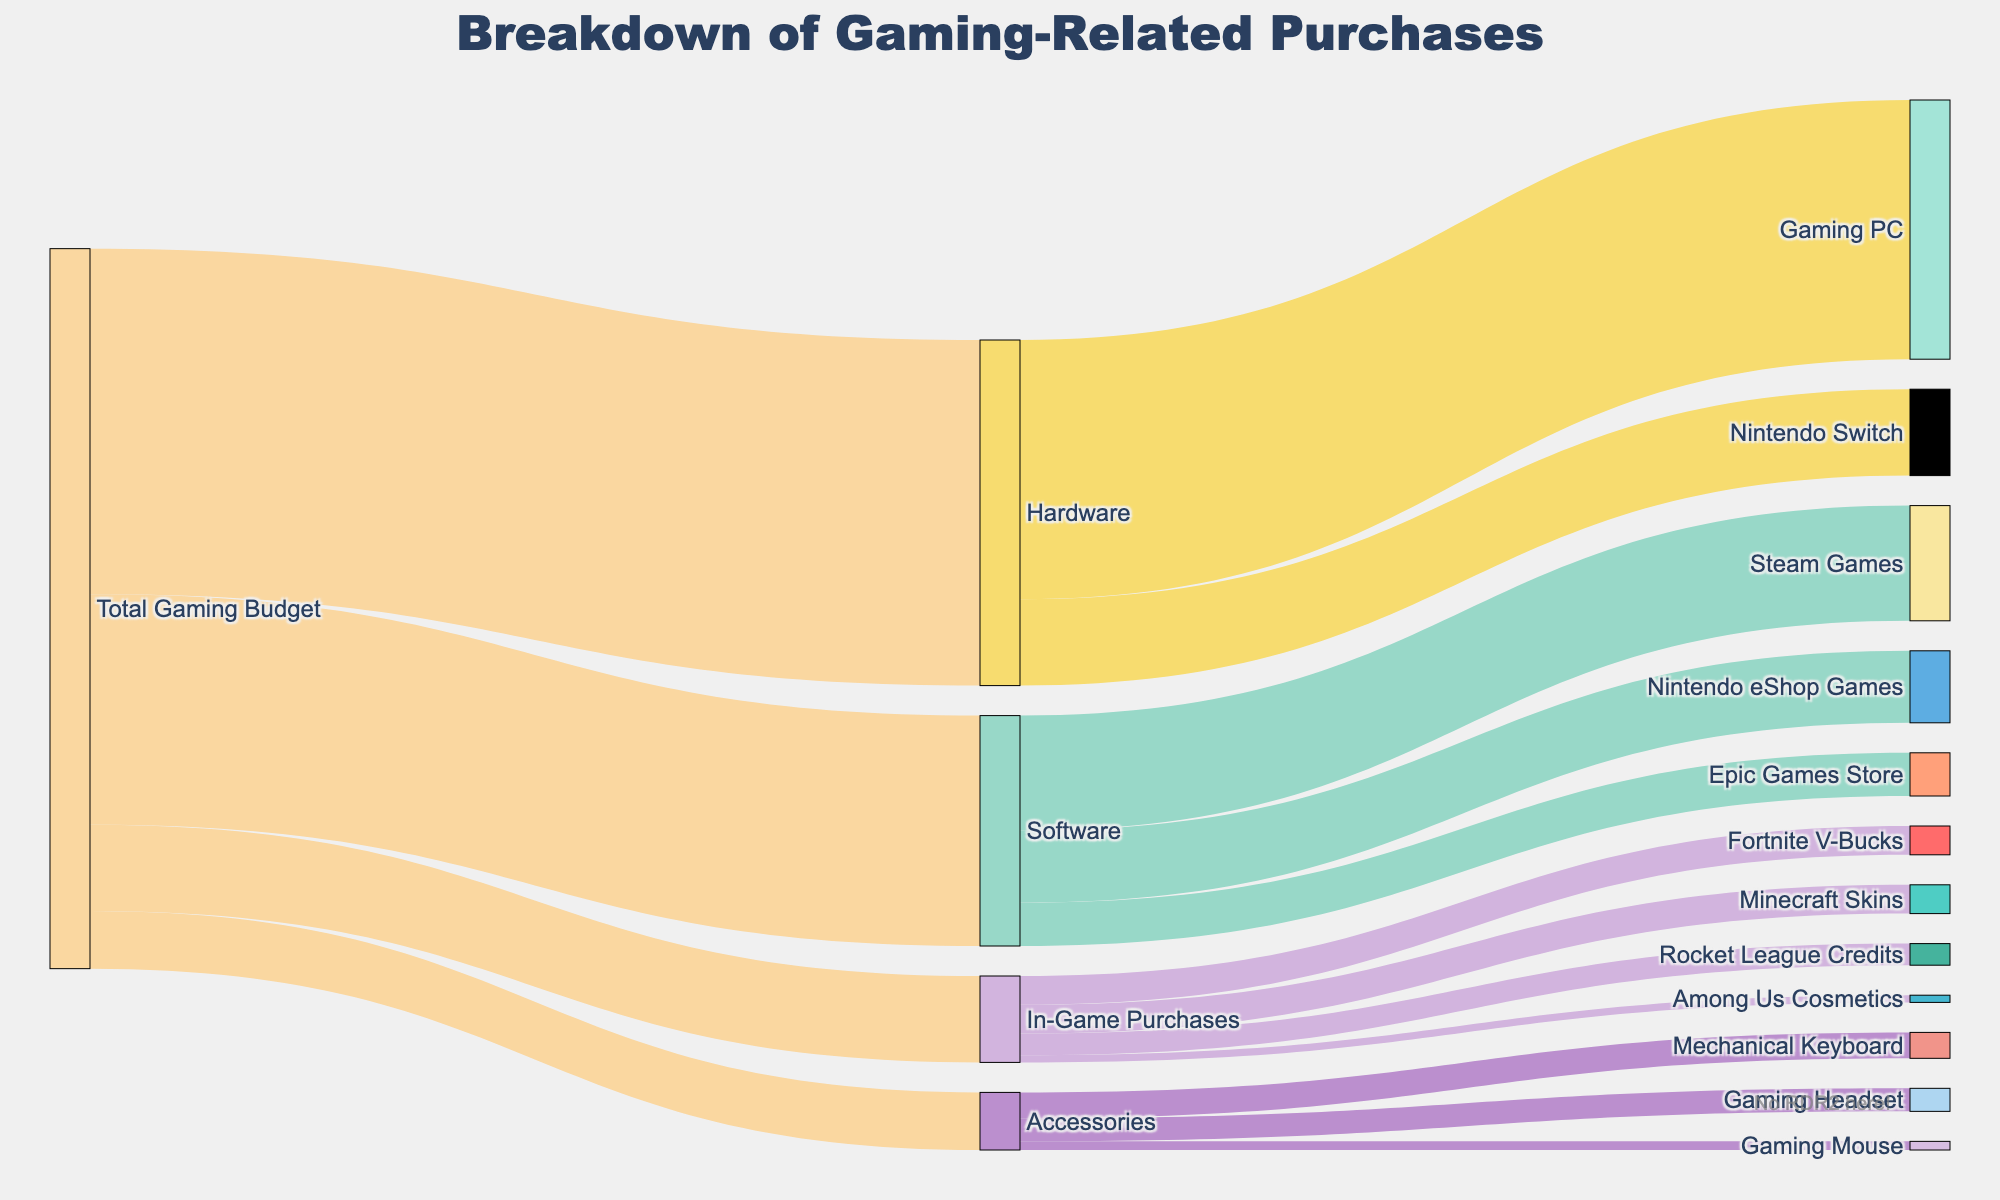How much is allocated to Hardware according to the diagram? Looking at the Sankey diagram, the flow from "Total Gaming Budget" to "Hardware" indicates the amount allocated.
Answer: 1200 Which category receives the least amount of money? By examining the flows from "Total Gaming Budget," we see the amounts are: Hardware (1200), Software (800), In-Game Purchases (300), and Accessories (200). The smallest amount is for Accessories.
Answer: Accessories How does the budget for Steam Games compare to Nintendo eShop Games? The Sankey diagram shows that "Steam Games" receive 400 and "Nintendo eShop Games" receive 250. Since 400 > 250, Steam Games receive more.
Answer: Steam Games receive more What is the sum of money spent on Gaming PC and Nintendo Switch? The amounts for "Gaming PC" and "Nintendo Switch" can be seen exiting from "Hardware." Summing them, we get 900 + 300 = 1200.
Answer: 1200 How much money is spent on Fortnite V-Bucks and Minecraft Skins combined? We see that "Fortnite V-Bucks" and "Minecraft Skins" are 100 each. Adding them results in 100 + 100 = 200.
Answer: 200 What percentage of the Total Gaming Budget is spent on Software? The total budget is 2500 (1200 + 800 + 300 + 200). Software expenditures are 800. So, (800 / 2500) * 100 = 32%.
Answer: 32% Is more money spent on Software or on Hardware? By viewing the diagram, we see that Software gets 800 while Hardware gets 1200. Hence, more is spent on Hardware.
Answer: Hardware Which in-game purchase has the highest expenditure? From the diagram, the in-game purchases are: Fortnite V-Bucks (100), Rocket League Credits (75), Among Us Cosmetics (25), Minecraft Skins (100). The highest is Fortnite V-Bucks.
Answer: Fortnite V-Bucks How much more is spent on a Mechanical Keyboard compared to a Gaming Mouse? The amounts for "Mechanical Keyboard" and "Gaming Mouse" are 90 and 30, respectively. The difference is 90 - 30 = 60.
Answer: 60 What is the combined total spent on Accessories? Accessories include Gaming Headset (80), Mechanical Keyboard (90), and Gaming Mouse (30). Adding these, we get 80 + 90 + 30 = 200.
Answer: 200 